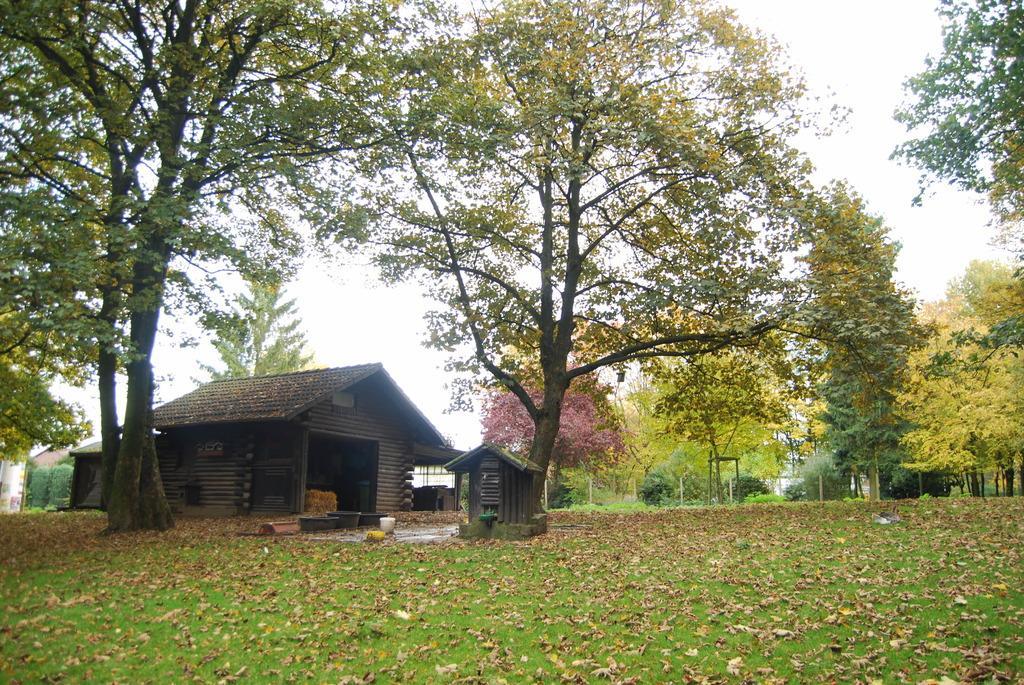In one or two sentences, can you explain what this image depicts? In this image I can see a house which is in brown and black color. We can see trees,fencing and few tubs. The sky is in white color. 